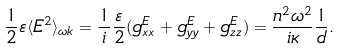Convert formula to latex. <formula><loc_0><loc_0><loc_500><loc_500>\frac { 1 } { 2 } \varepsilon \langle E ^ { 2 } \rangle _ { \omega k } = \frac { 1 } { i } \frac { \varepsilon } { 2 } ( g ^ { E } _ { x x } + g ^ { E } _ { y y } + g ^ { E } _ { z z } ) = \frac { n ^ { 2 } \omega ^ { 2 } } { i \kappa } \frac { 1 } { d } .</formula> 